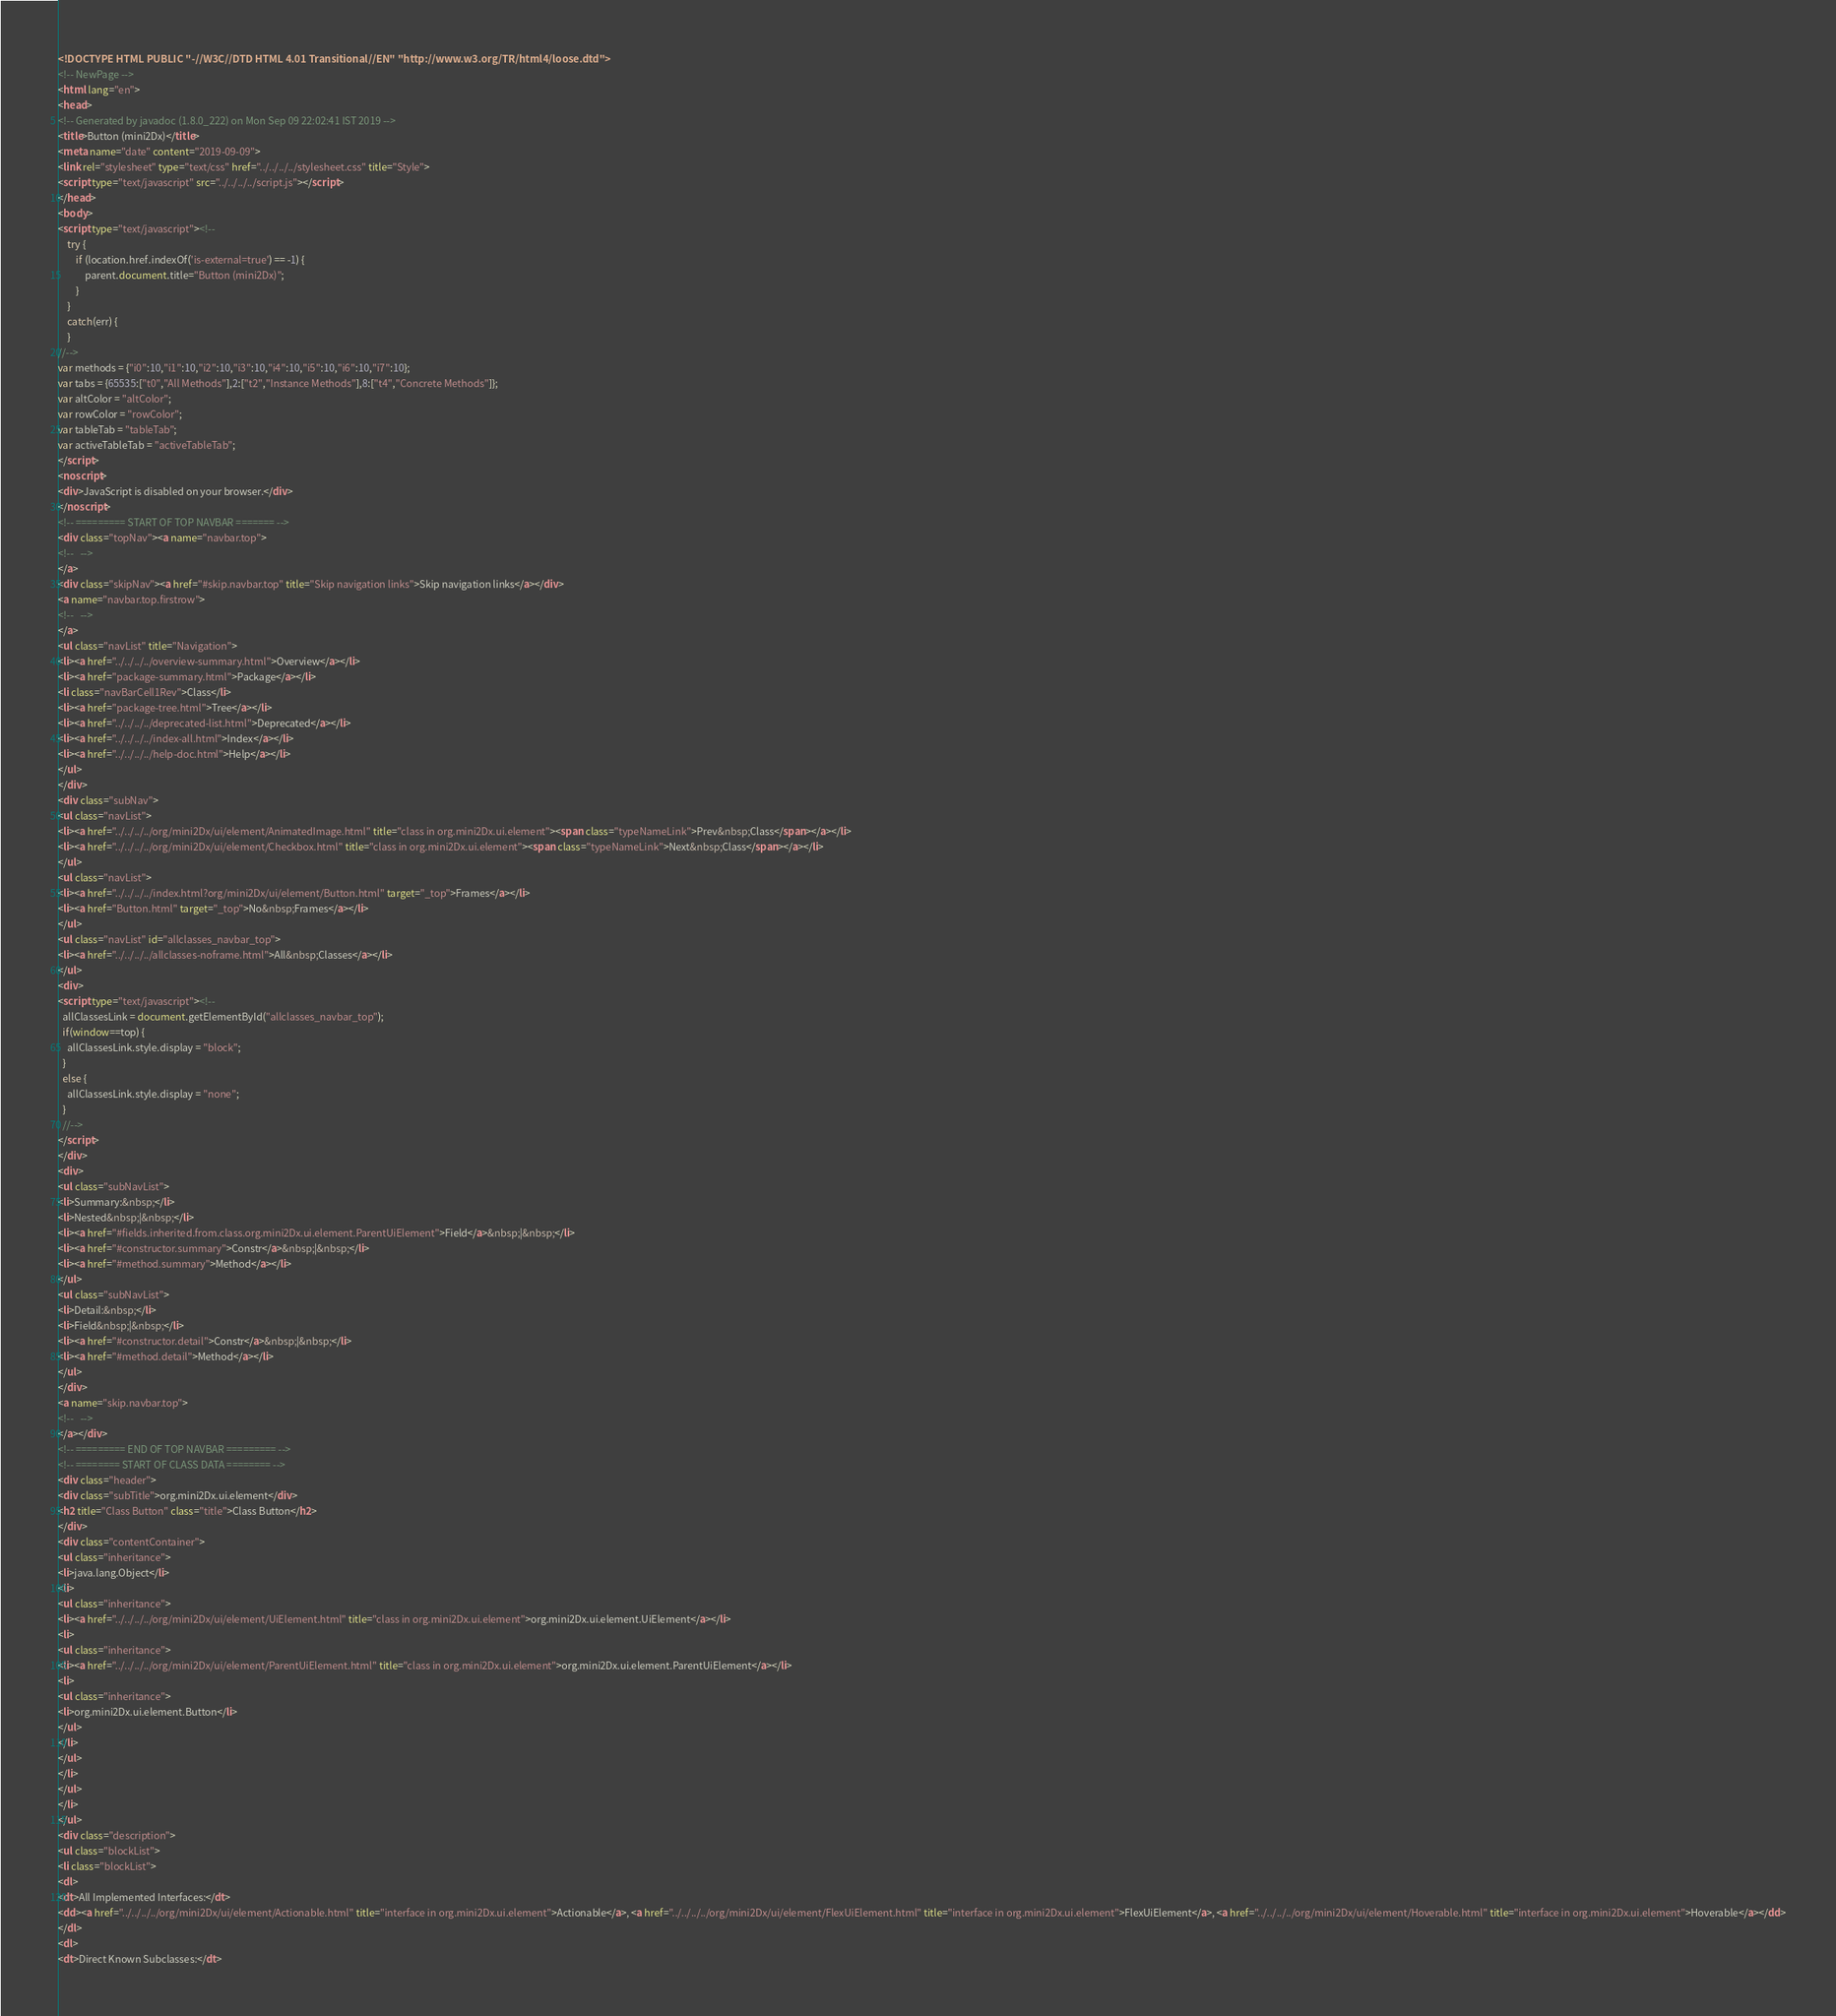Convert code to text. <code><loc_0><loc_0><loc_500><loc_500><_HTML_><!DOCTYPE HTML PUBLIC "-//W3C//DTD HTML 4.01 Transitional//EN" "http://www.w3.org/TR/html4/loose.dtd">
<!-- NewPage -->
<html lang="en">
<head>
<!-- Generated by javadoc (1.8.0_222) on Mon Sep 09 22:02:41 IST 2019 -->
<title>Button (mini2Dx)</title>
<meta name="date" content="2019-09-09">
<link rel="stylesheet" type="text/css" href="../../../../stylesheet.css" title="Style">
<script type="text/javascript" src="../../../../script.js"></script>
</head>
<body>
<script type="text/javascript"><!--
    try {
        if (location.href.indexOf('is-external=true') == -1) {
            parent.document.title="Button (mini2Dx)";
        }
    }
    catch(err) {
    }
//-->
var methods = {"i0":10,"i1":10,"i2":10,"i3":10,"i4":10,"i5":10,"i6":10,"i7":10};
var tabs = {65535:["t0","All Methods"],2:["t2","Instance Methods"],8:["t4","Concrete Methods"]};
var altColor = "altColor";
var rowColor = "rowColor";
var tableTab = "tableTab";
var activeTableTab = "activeTableTab";
</script>
<noscript>
<div>JavaScript is disabled on your browser.</div>
</noscript>
<!-- ========= START OF TOP NAVBAR ======= -->
<div class="topNav"><a name="navbar.top">
<!--   -->
</a>
<div class="skipNav"><a href="#skip.navbar.top" title="Skip navigation links">Skip navigation links</a></div>
<a name="navbar.top.firstrow">
<!--   -->
</a>
<ul class="navList" title="Navigation">
<li><a href="../../../../overview-summary.html">Overview</a></li>
<li><a href="package-summary.html">Package</a></li>
<li class="navBarCell1Rev">Class</li>
<li><a href="package-tree.html">Tree</a></li>
<li><a href="../../../../deprecated-list.html">Deprecated</a></li>
<li><a href="../../../../index-all.html">Index</a></li>
<li><a href="../../../../help-doc.html">Help</a></li>
</ul>
</div>
<div class="subNav">
<ul class="navList">
<li><a href="../../../../org/mini2Dx/ui/element/AnimatedImage.html" title="class in org.mini2Dx.ui.element"><span class="typeNameLink">Prev&nbsp;Class</span></a></li>
<li><a href="../../../../org/mini2Dx/ui/element/Checkbox.html" title="class in org.mini2Dx.ui.element"><span class="typeNameLink">Next&nbsp;Class</span></a></li>
</ul>
<ul class="navList">
<li><a href="../../../../index.html?org/mini2Dx/ui/element/Button.html" target="_top">Frames</a></li>
<li><a href="Button.html" target="_top">No&nbsp;Frames</a></li>
</ul>
<ul class="navList" id="allclasses_navbar_top">
<li><a href="../../../../allclasses-noframe.html">All&nbsp;Classes</a></li>
</ul>
<div>
<script type="text/javascript"><!--
  allClassesLink = document.getElementById("allclasses_navbar_top");
  if(window==top) {
    allClassesLink.style.display = "block";
  }
  else {
    allClassesLink.style.display = "none";
  }
  //-->
</script>
</div>
<div>
<ul class="subNavList">
<li>Summary:&nbsp;</li>
<li>Nested&nbsp;|&nbsp;</li>
<li><a href="#fields.inherited.from.class.org.mini2Dx.ui.element.ParentUiElement">Field</a>&nbsp;|&nbsp;</li>
<li><a href="#constructor.summary">Constr</a>&nbsp;|&nbsp;</li>
<li><a href="#method.summary">Method</a></li>
</ul>
<ul class="subNavList">
<li>Detail:&nbsp;</li>
<li>Field&nbsp;|&nbsp;</li>
<li><a href="#constructor.detail">Constr</a>&nbsp;|&nbsp;</li>
<li><a href="#method.detail">Method</a></li>
</ul>
</div>
<a name="skip.navbar.top">
<!--   -->
</a></div>
<!-- ========= END OF TOP NAVBAR ========= -->
<!-- ======== START OF CLASS DATA ======== -->
<div class="header">
<div class="subTitle">org.mini2Dx.ui.element</div>
<h2 title="Class Button" class="title">Class Button</h2>
</div>
<div class="contentContainer">
<ul class="inheritance">
<li>java.lang.Object</li>
<li>
<ul class="inheritance">
<li><a href="../../../../org/mini2Dx/ui/element/UiElement.html" title="class in org.mini2Dx.ui.element">org.mini2Dx.ui.element.UiElement</a></li>
<li>
<ul class="inheritance">
<li><a href="../../../../org/mini2Dx/ui/element/ParentUiElement.html" title="class in org.mini2Dx.ui.element">org.mini2Dx.ui.element.ParentUiElement</a></li>
<li>
<ul class="inheritance">
<li>org.mini2Dx.ui.element.Button</li>
</ul>
</li>
</ul>
</li>
</ul>
</li>
</ul>
<div class="description">
<ul class="blockList">
<li class="blockList">
<dl>
<dt>All Implemented Interfaces:</dt>
<dd><a href="../../../../org/mini2Dx/ui/element/Actionable.html" title="interface in org.mini2Dx.ui.element">Actionable</a>, <a href="../../../../org/mini2Dx/ui/element/FlexUiElement.html" title="interface in org.mini2Dx.ui.element">FlexUiElement</a>, <a href="../../../../org/mini2Dx/ui/element/Hoverable.html" title="interface in org.mini2Dx.ui.element">Hoverable</a></dd>
</dl>
<dl>
<dt>Direct Known Subclasses:</dt></code> 